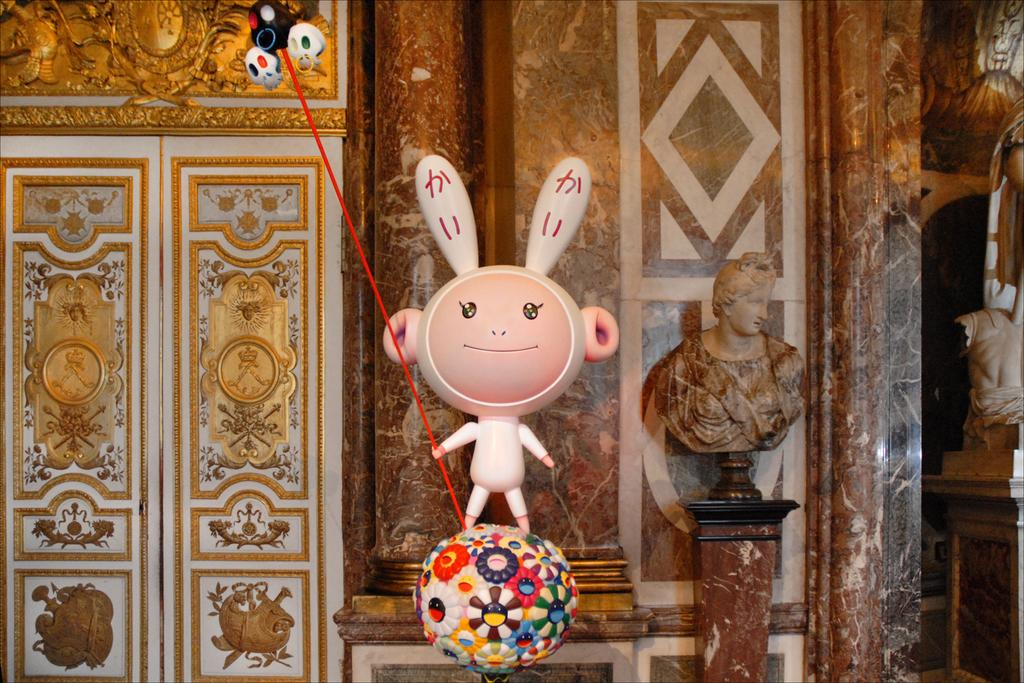What is the main object in the middle of the image? There is a toy in the middle of the image. What other object can be seen in the image? There is a ball in the image. How many doors are visible on the left side of the image? There are two doors on the left side of the image. What is located on the right side of the image? There is a statue on the right side of the image. How many tomatoes are hanging from the statue in the image? There are no tomatoes present in the image, and the statue does not have any hanging from it. 